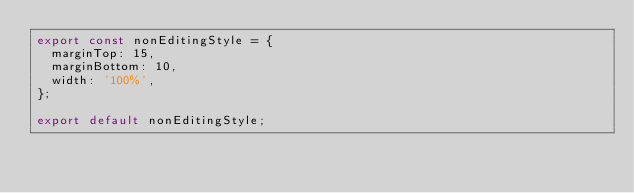Convert code to text. <code><loc_0><loc_0><loc_500><loc_500><_JavaScript_>export const nonEditingStyle = {
  marginTop: 15,
  marginBottom: 10,
  width: '100%',
};

export default nonEditingStyle;
</code> 